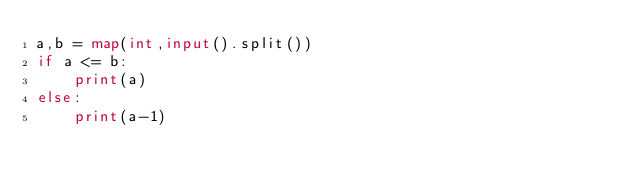Convert code to text. <code><loc_0><loc_0><loc_500><loc_500><_Python_>a,b = map(int,input().split())
if a <= b:
    print(a)
else:
    print(a-1)</code> 